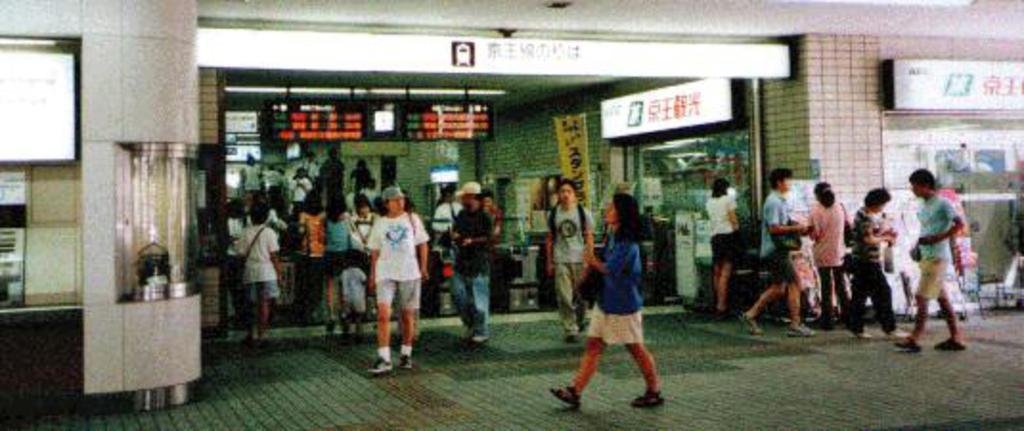Could you give a brief overview of what you see in this image? There are persons in different color dresses on the footpath. In the background, there are hoardings and screens, there are persons and there is a building. 